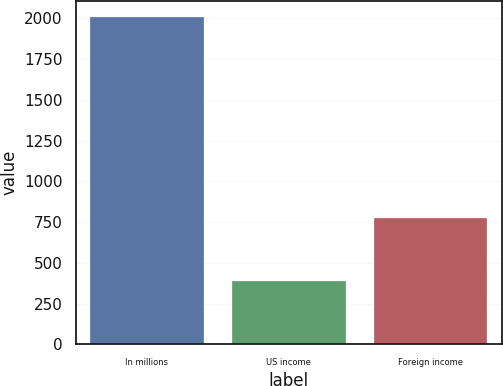Convert chart. <chart><loc_0><loc_0><loc_500><loc_500><bar_chart><fcel>In millions<fcel>US income<fcel>Foreign income<nl><fcel>2007<fcel>391<fcel>778<nl></chart> 